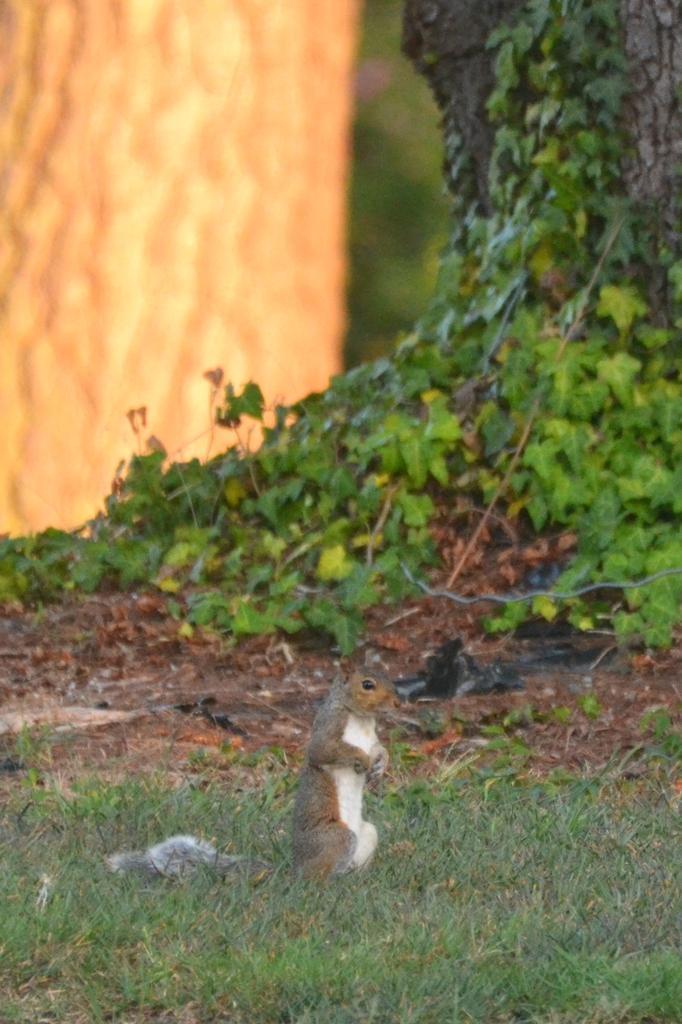How would you summarize this image in a sentence or two? In this image, we can see a squirrel on the grass. Background we can see few plants and tree trunk. Here there is a blur view. 